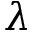Convert formula to latex. <formula><loc_0><loc_0><loc_500><loc_500>{ \boldsymbol \lambda }</formula> 